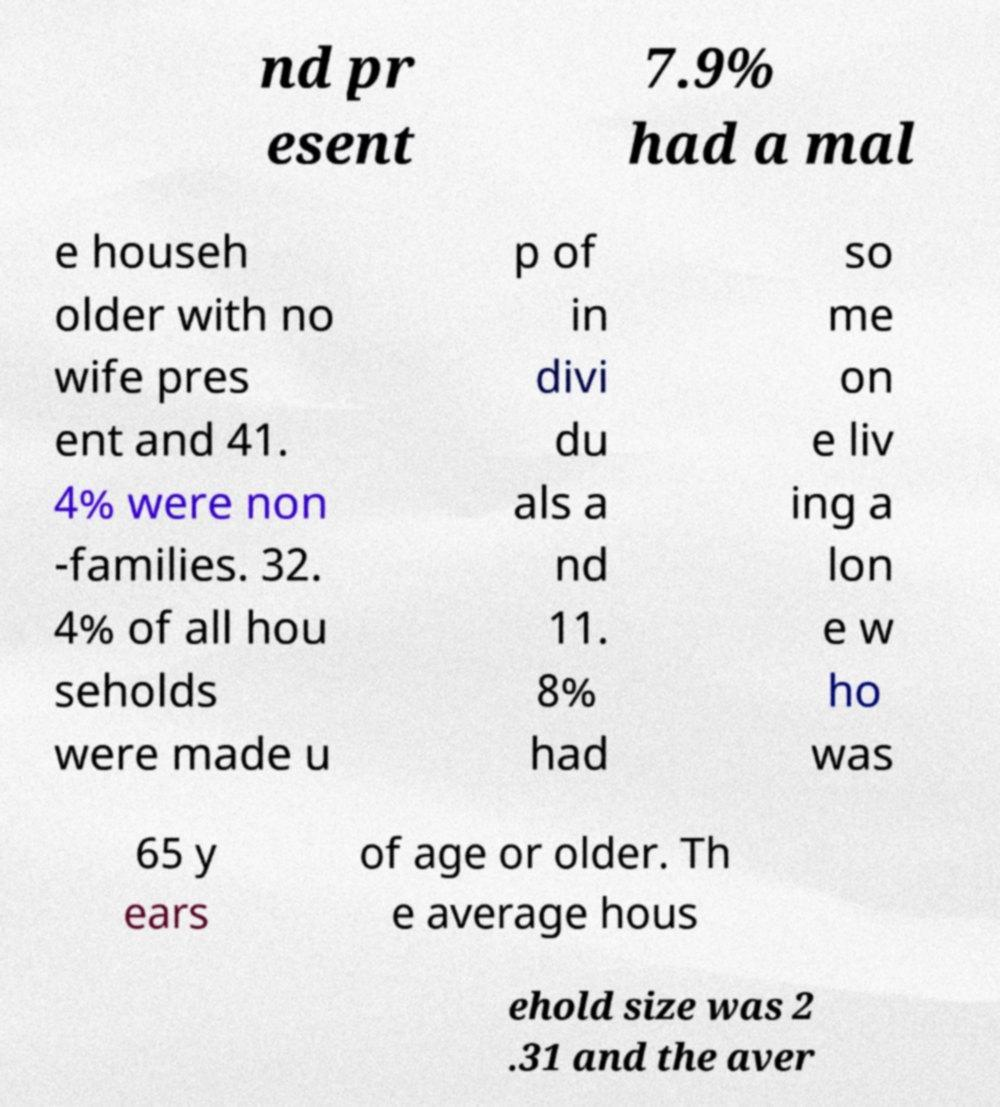Please identify and transcribe the text found in this image. nd pr esent 7.9% had a mal e househ older with no wife pres ent and 41. 4% were non -families. 32. 4% of all hou seholds were made u p of in divi du als a nd 11. 8% had so me on e liv ing a lon e w ho was 65 y ears of age or older. Th e average hous ehold size was 2 .31 and the aver 